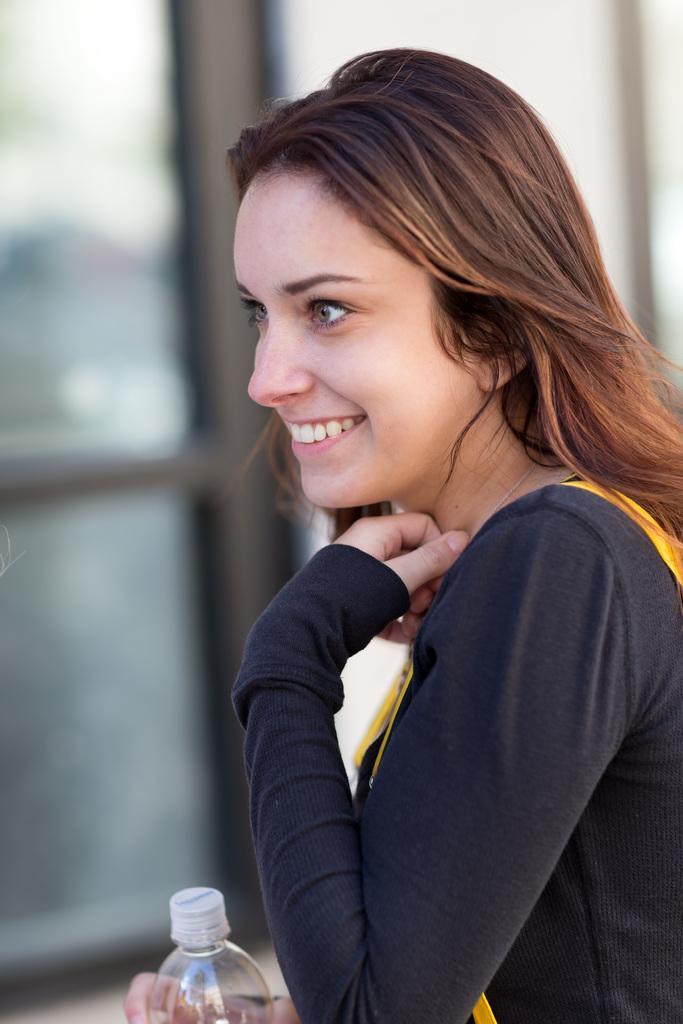Could you give a brief overview of what you see in this image? As we can see in the image there is a woman wearing black color shirt and holding a bottle and the background is blurry. 